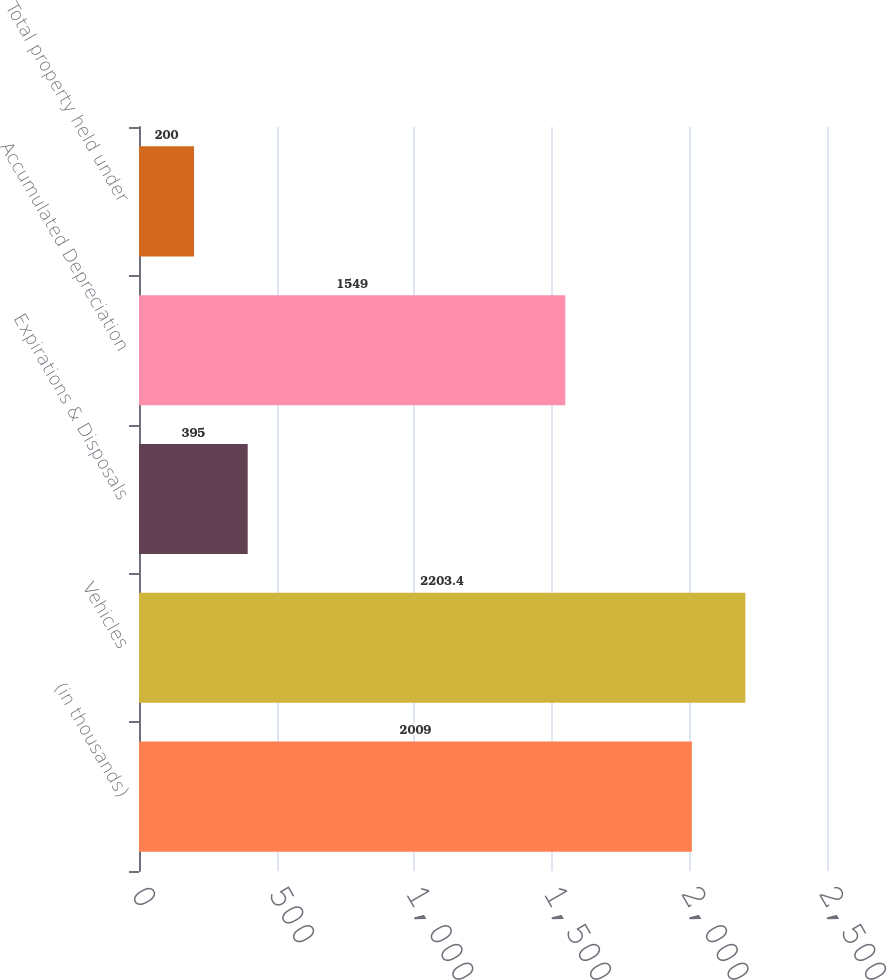Convert chart to OTSL. <chart><loc_0><loc_0><loc_500><loc_500><bar_chart><fcel>(in thousands)<fcel>Vehicles<fcel>Expirations & Disposals<fcel>Accumulated Depreciation<fcel>Total property held under<nl><fcel>2009<fcel>2203.4<fcel>395<fcel>1549<fcel>200<nl></chart> 